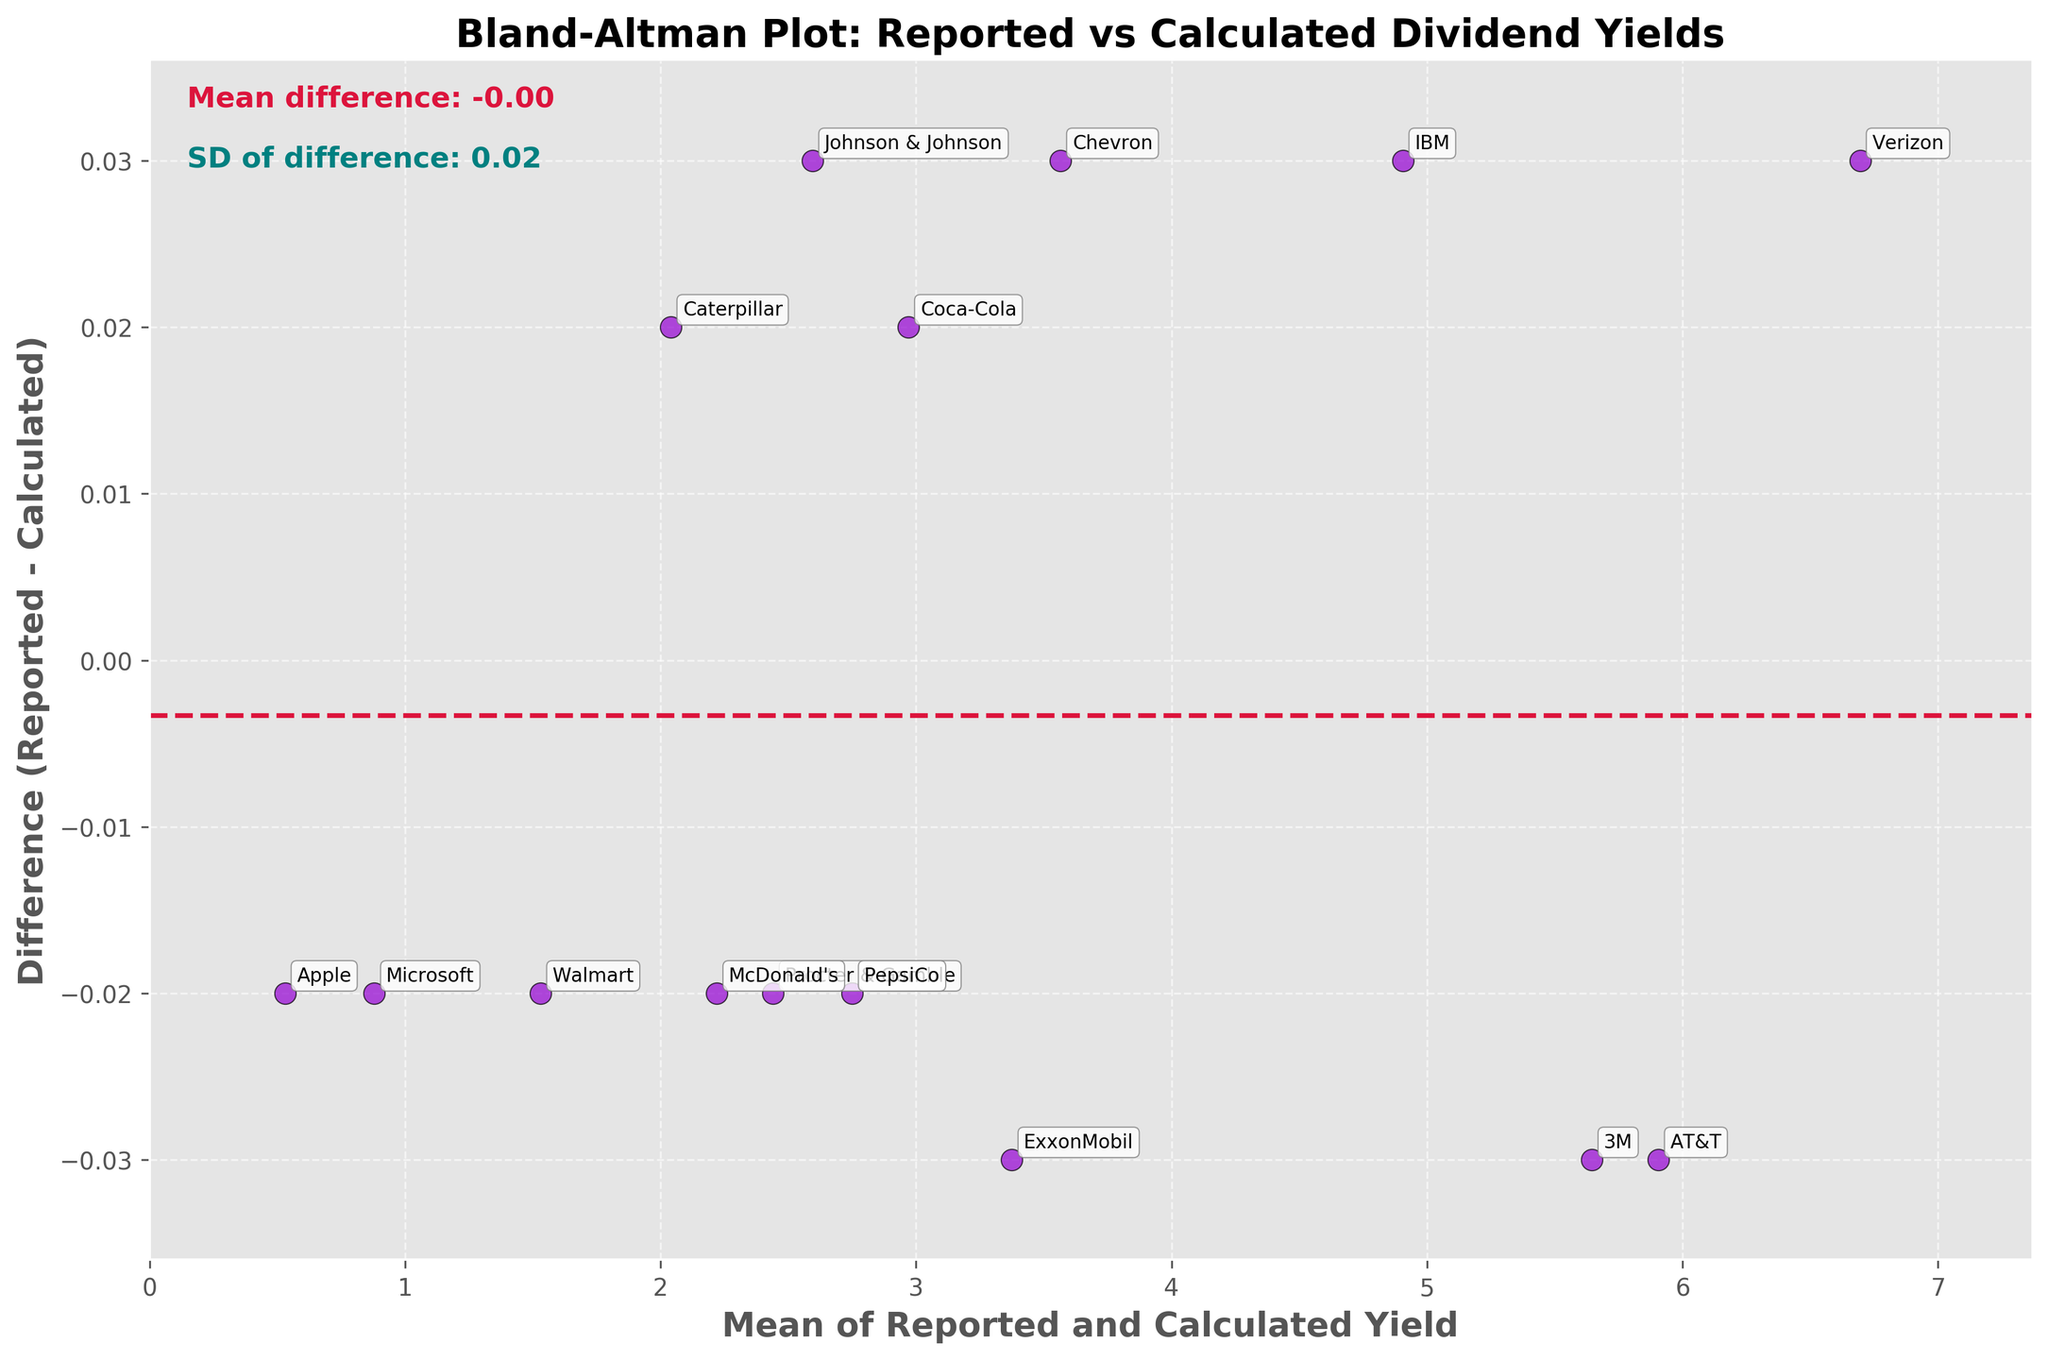What's the title of the plot? The title is present at the top of the figure, which provides a summary representation of the content. It helps the viewer quickly understand the purpose of the plot.
Answer: Bland-Altman Plot: Reported vs Calculated Dividend Yields How many companies are represented in this plot? Each scatter point on the plot represents one company. By counting the points or annotations, we can determine the total number of companies shown.
Answer: 15 What is the mean difference between the reported and calculated yields? The mean difference is provided as a text annotation on the plot, usually located around the top-left corner. It summarizes the average bias.
Answer: Mean difference: -0.01 Where are the limits of agreement lines on the plot? Limits of agreement lines are set at mean ± 1.96 times the standard deviation. These are visually represented on the plot with dotted lines.
Answer: At approximately ±0.04 around the mean difference What is the color of the scatter points? The scatter points are marked with a specific color to distinguish between data points and other elements of the plot, enhancing visual clarity.
Answer: Darkviolet Which company has the largest absolute difference between reported and calculated yields? By identifying the data point furthest from the zero line and looking at the corresponding annotation, we can determine the company with the largest difference.
Answer: Verizon Is there any company with a perfect match between reported and calculated yields? For a perfect match, the difference would be zero. We need to check if any scatter points lie on the zero line of the y-axis.
Answer: No Which company has the highest mean yield between reported and calculated values? By locating the furthest right point on the x-axis and identifying the closest annotation, we can find the company with the highest mean yield.
Answer: Verizon What's the standard deviation of the differences? The plot may annotate the standard deviation of the differences, often found near the mean difference annotation.
Answer: SD of difference: 0.01 